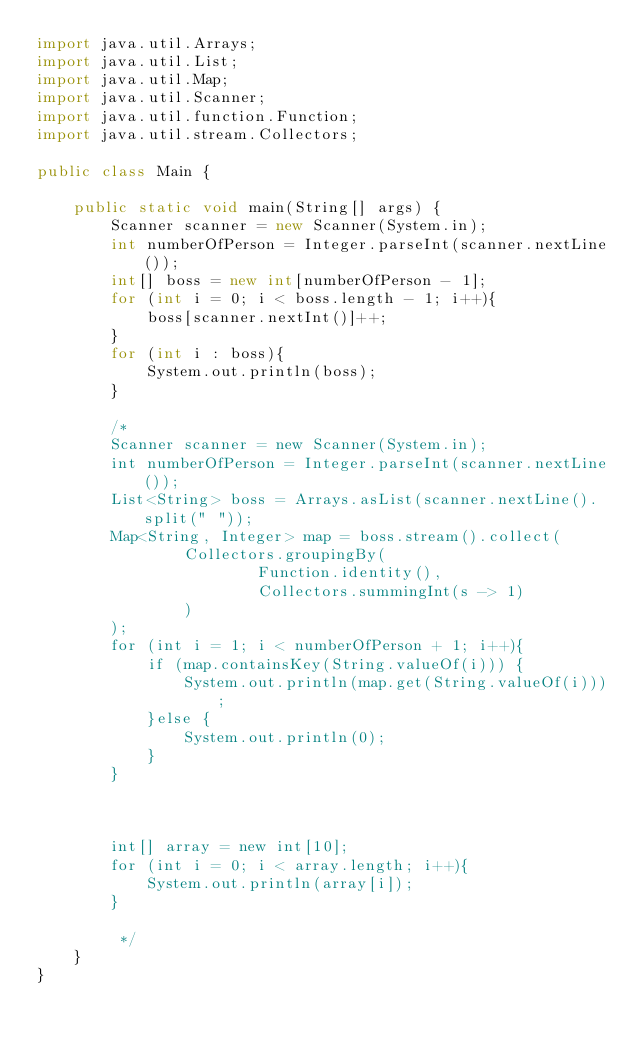<code> <loc_0><loc_0><loc_500><loc_500><_Java_>import java.util.Arrays;
import java.util.List;
import java.util.Map;
import java.util.Scanner;
import java.util.function.Function;
import java.util.stream.Collectors;

public class Main {

    public static void main(String[] args) {
        Scanner scanner = new Scanner(System.in);
        int numberOfPerson = Integer.parseInt(scanner.nextLine());
        int[] boss = new int[numberOfPerson - 1];
        for (int i = 0; i < boss.length - 1; i++){
            boss[scanner.nextInt()]++;
        }
        for (int i : boss){
            System.out.println(boss);
        }

        /*
        Scanner scanner = new Scanner(System.in);
        int numberOfPerson = Integer.parseInt(scanner.nextLine());
        List<String> boss = Arrays.asList(scanner.nextLine().split(" "));
        Map<String, Integer> map = boss.stream().collect(
                Collectors.groupingBy(
                        Function.identity(),
                        Collectors.summingInt(s -> 1)
                )
        );
        for (int i = 1; i < numberOfPerson + 1; i++){
            if (map.containsKey(String.valueOf(i))) {
                System.out.println(map.get(String.valueOf(i)));
            }else {
                System.out.println(0);
            }
        }



        int[] array = new int[10];
        for (int i = 0; i < array.length; i++){
            System.out.println(array[i]);
        }

         */
    }
}
</code> 